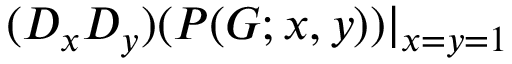<formula> <loc_0><loc_0><loc_500><loc_500>( D _ { x } D _ { y } ) ( P ( G ; x , y ) ) | _ { x = y = 1 }</formula> 